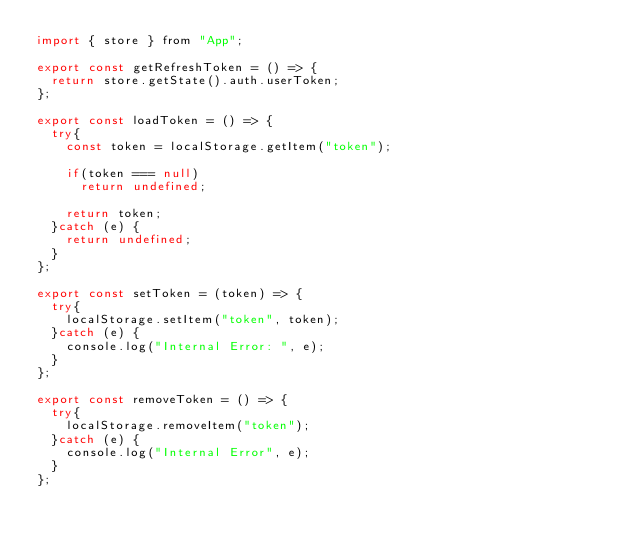<code> <loc_0><loc_0><loc_500><loc_500><_JavaScript_>import { store } from "App";

export const getRefreshToken = () => {
  return store.getState().auth.userToken;
};

export const loadToken = () => {
  try{
    const token = localStorage.getItem("token");

    if(token === null)
      return undefined;

    return token;
  }catch (e) {
    return undefined;
  }
};

export const setToken = (token) => {
  try{
    localStorage.setItem("token", token);
  }catch (e) {
    console.log("Internal Error: ", e);
  }
};

export const removeToken = () => {
  try{
    localStorage.removeItem("token");
  }catch (e) {
    console.log("Internal Error", e);
  }
};
</code> 